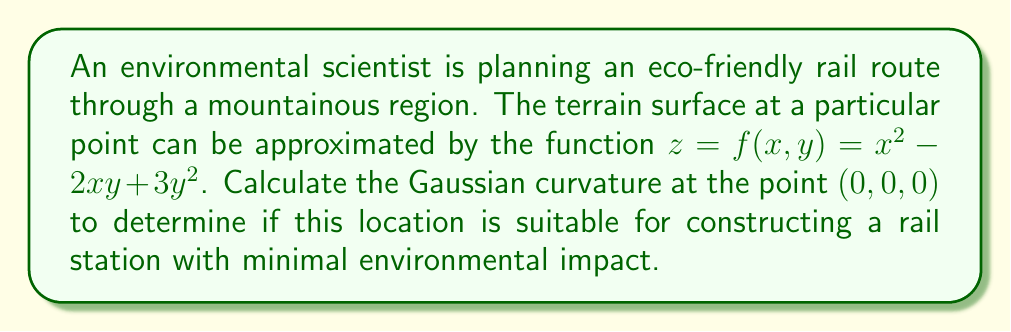Provide a solution to this math problem. To compute the Gaussian curvature, we need to follow these steps:

1) The Gaussian curvature K is given by:

   $$K = \frac{LN - M^2}{EG - F^2}$$

   where L, M, N are the coefficients of the second fundamental form, and E, F, G are the coefficients of the first fundamental form.

2) For a surface given by $z = f(x,y)$, we have:

   $$E = 1 + f_x^2$$
   $$F = f_x f_y$$
   $$G = 1 + f_y^2$$
   $$L = \frac{f_{xx}}{\sqrt{1 + f_x^2 + f_y^2}}$$
   $$M = \frac{f_{xy}}{\sqrt{1 + f_x^2 + f_y^2}}$$
   $$N = \frac{f_{yy}}{\sqrt{1 + f_x^2 + f_y^2}}$$

3) Let's calculate the partial derivatives:

   $f_x = 2x - 2y$
   $f_y = -2x + 6y$
   $f_{xx} = 2$
   $f_{xy} = -2$
   $f_{yy} = 6$

4) At the point (0,0,0):

   $f_x = 0$
   $f_y = 0$
   $f_{xx} = 2$
   $f_{xy} = -2$
   $f_{yy} = 6$

5) Now we can calculate E, F, G, L, M, N at (0,0,0):

   $E = 1 + 0^2 = 1$
   $F = 0 \cdot 0 = 0$
   $G = 1 + 0^2 = 1$
   $L = \frac{2}{\sqrt{1 + 0^2 + 0^2}} = 2$
   $M = \frac{-2}{\sqrt{1 + 0^2 + 0^2}} = -2$
   $N = \frac{6}{\sqrt{1 + 0^2 + 0^2}} = 6$

6) Finally, we can compute the Gaussian curvature:

   $$K = \frac{LN - M^2}{EG - F^2} = \frac{2 \cdot 6 - (-2)^2}{1 \cdot 1 - 0^2} = \frac{12 - 4}{1} = 8$$

Therefore, the Gaussian curvature at the point (0,0,0) is 8.
Answer: $K = 8$ 